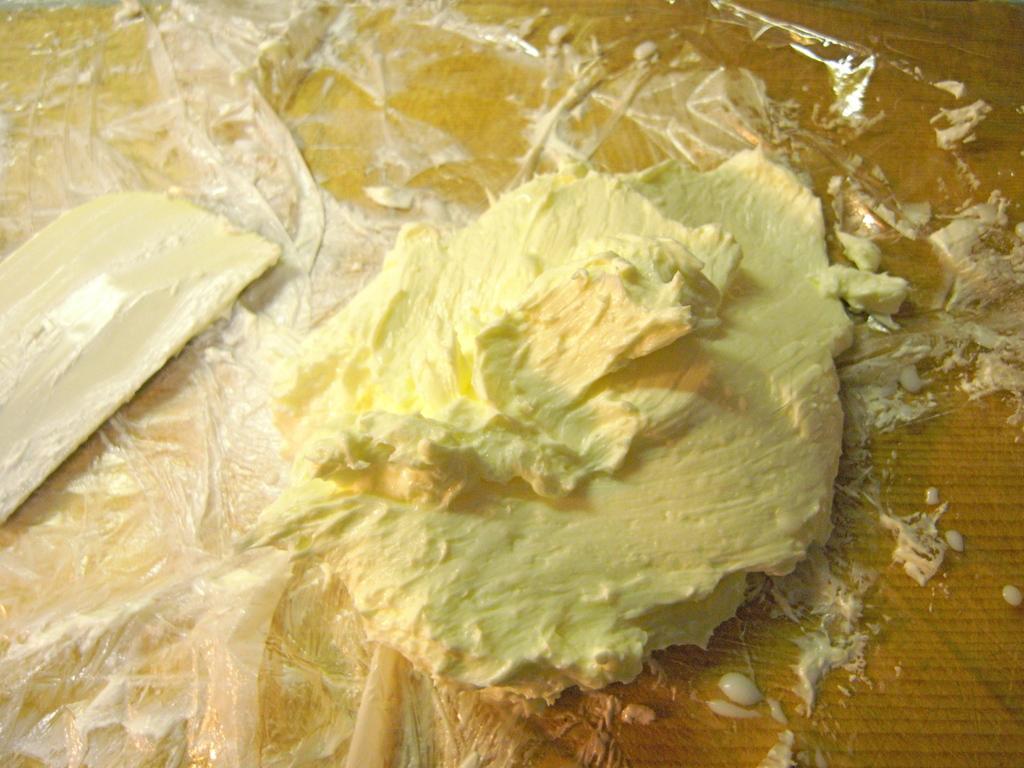Describe this image in one or two sentences. In this image I can see the butter in yellow and cream color. It is on the plastic-cover. The cover is on the brown color surface. 